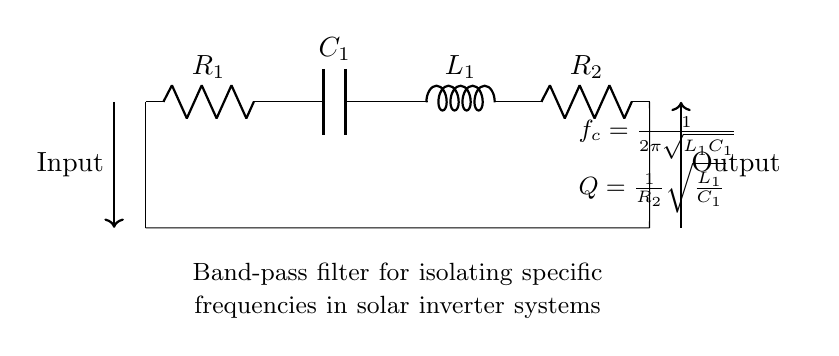What is the type of filter represented in the circuit? The circuit depicts a band-pass filter, which is specifically designed to isolate particular frequencies while attenuating others. This can be inferred from the label in the diagram, which clearly states its purpose as a band-pass filter for solar inverter systems.
Answer: band-pass filter What components are used in this band-pass filter? The band-pass filter consists of two resistors (R1 and R2), one capacitor (C1), and one inductor (L1). These components are all labeled in the circuit diagram, confirming their presence and roles in the filter operation.
Answer: R1, R2, C1, L1 What is the formula for the cut-off frequency? The cut-off frequency is calculated using the formula provided in the circuit diagram: f_c = 1/(2π√(L1C1)). This is the standard formula for the resonant frequency of an LC circuit, highlighting how the inductor and capacitor interact to define the frequency at which the filter operates optimally.
Answer: 1/(2π√(L1C1)) What is the quality factor (Q) of the filter? The quality factor Q is given by the formula Q = 1/R2√(L1/C1), as depicted in the circuit. The quality factor is a dimensionless parameter that describes how underdamped a filter is, indicating the selectivity and bandwidth of the band-pass filter.
Answer: 1/R2√(L1/C1) How many energy storage elements are present in the circuit? The circuit has two types of energy storage elements: one capacitor (C1) and one inductor (L1), totaling two energy storage components where energy can be temporarily held in the circuit.
Answer: 2 